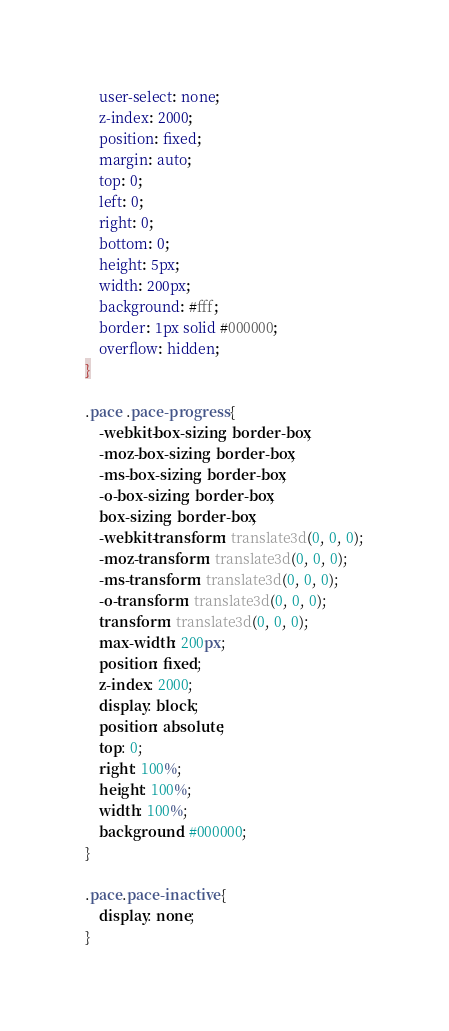Convert code to text. <code><loc_0><loc_0><loc_500><loc_500><_CSS_>	user-select: none;
	z-index: 2000;
	position: fixed;
	margin: auto;
	top: 0;
	left: 0;
	right: 0;
	bottom: 0;
	height: 5px;
	width: 200px;
	background: #fff;
	border: 1px solid #000000;
	overflow: hidden;
}

.pace .pace-progress {
	-webkit-box-sizing: border-box;
	-moz-box-sizing: border-box;
	-ms-box-sizing: border-box;
	-o-box-sizing: border-box;
	box-sizing: border-box;
	-webkit-transform: translate3d(0, 0, 0);
	-moz-transform: translate3d(0, 0, 0);
	-ms-transform: translate3d(0, 0, 0);
	-o-transform: translate3d(0, 0, 0);
	transform: translate3d(0, 0, 0);
	max-width: 200px;
	position: fixed;
	z-index: 2000;
	display: block;
	position: absolute;
	top: 0;
	right: 100%;
	height: 100%;
	width: 100%;
	background: #000000;
}

.pace.pace-inactive {
	display: none;
}</code> 